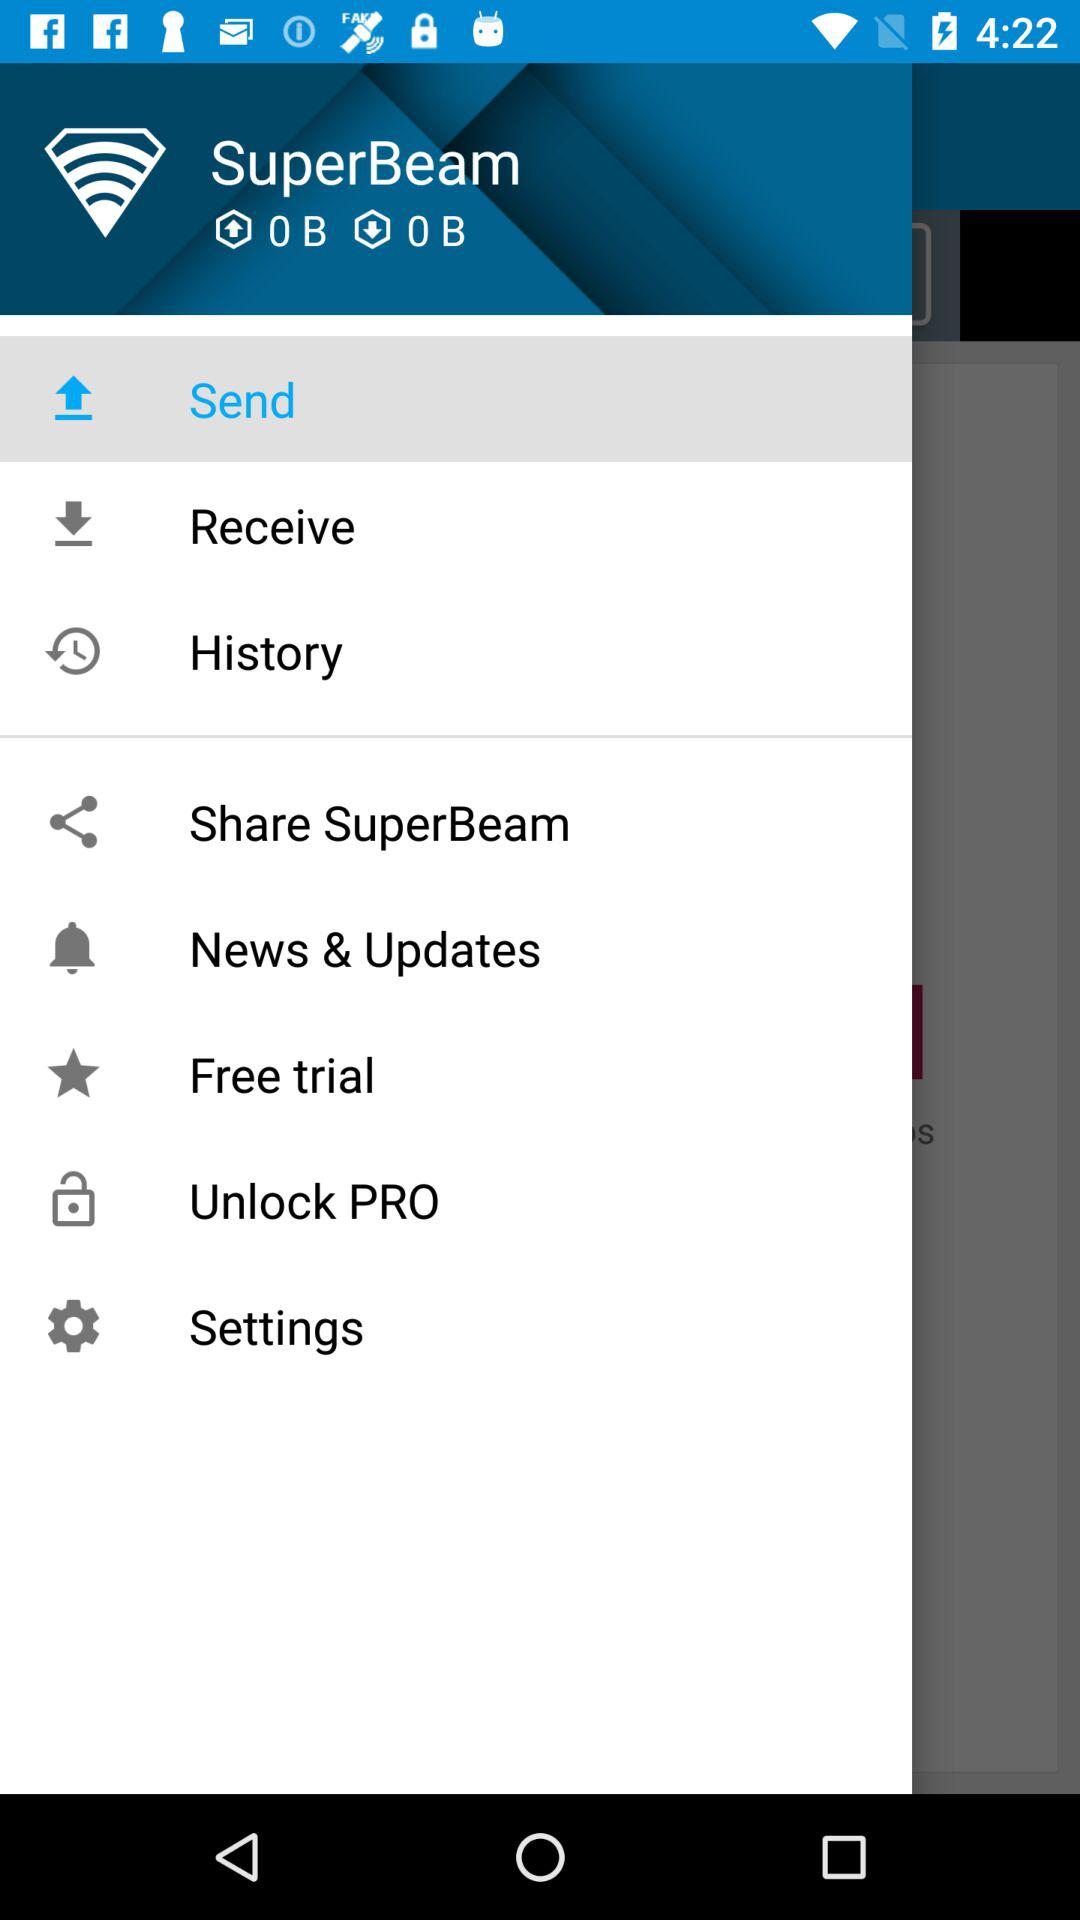What is the application name? The application name is "SuperBeam". 